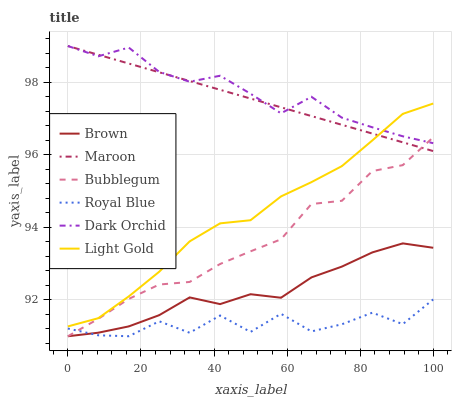Does Royal Blue have the minimum area under the curve?
Answer yes or no. Yes. Does Dark Orchid have the maximum area under the curve?
Answer yes or no. Yes. Does Maroon have the minimum area under the curve?
Answer yes or no. No. Does Maroon have the maximum area under the curve?
Answer yes or no. No. Is Maroon the smoothest?
Answer yes or no. Yes. Is Royal Blue the roughest?
Answer yes or no. Yes. Is Dark Orchid the smoothest?
Answer yes or no. No. Is Dark Orchid the roughest?
Answer yes or no. No. Does Brown have the lowest value?
Answer yes or no. Yes. Does Maroon have the lowest value?
Answer yes or no. No. Does Dark Orchid have the highest value?
Answer yes or no. Yes. Does Royal Blue have the highest value?
Answer yes or no. No. Is Bubblegum less than Light Gold?
Answer yes or no. Yes. Is Dark Orchid greater than Brown?
Answer yes or no. Yes. Does Bubblegum intersect Brown?
Answer yes or no. Yes. Is Bubblegum less than Brown?
Answer yes or no. No. Is Bubblegum greater than Brown?
Answer yes or no. No. Does Bubblegum intersect Light Gold?
Answer yes or no. No. 